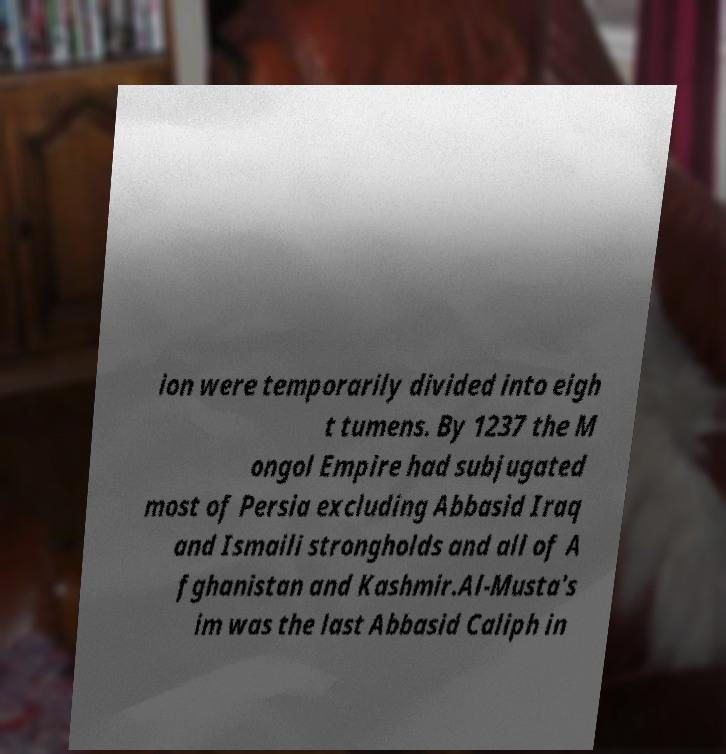Can you accurately transcribe the text from the provided image for me? ion were temporarily divided into eigh t tumens. By 1237 the M ongol Empire had subjugated most of Persia excluding Abbasid Iraq and Ismaili strongholds and all of A fghanistan and Kashmir.Al-Musta's im was the last Abbasid Caliph in 